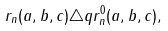Convert formula to latex. <formula><loc_0><loc_0><loc_500><loc_500>r _ { n } ( a , b , c ) \triangle q r ^ { 0 } _ { n } ( a , b , c ) ,</formula> 